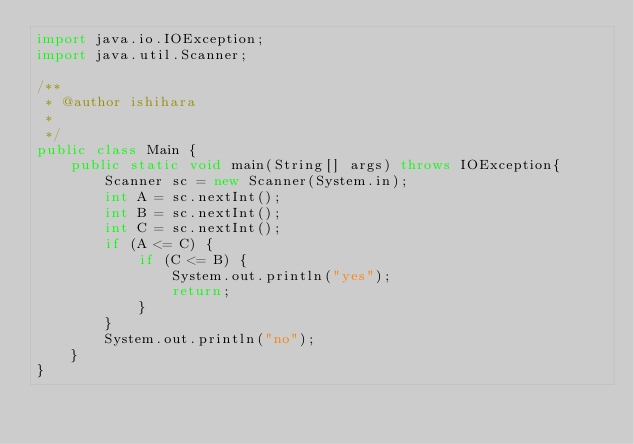<code> <loc_0><loc_0><loc_500><loc_500><_Java_>import java.io.IOException;
import java.util.Scanner;

/**
 * @author ishihara
 *
 */
public class Main {
    public static void main(String[] args) throws IOException{
        Scanner sc = new Scanner(System.in);
        int A = sc.nextInt();
        int B = sc.nextInt();
        int C = sc.nextInt();
        if (A <= C) {
            if (C <= B) {
                System.out.println("yes");
                return;
            }
        }
        System.out.println("no");
    }
}</code> 